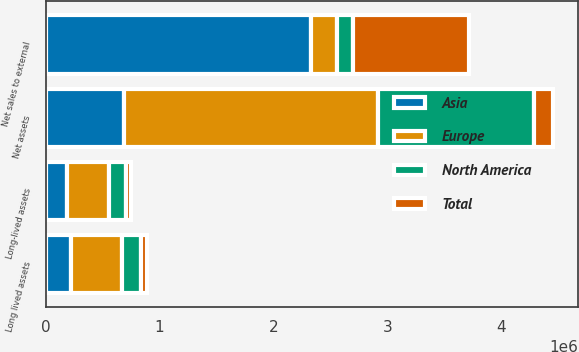Convert chart. <chart><loc_0><loc_0><loc_500><loc_500><stacked_bar_chart><ecel><fcel>Net sales to external<fcel>Long lived assets<fcel>Net assets<fcel>Long-lived assets<nl><fcel>Asia<fcel>2.33358e+06<fcel>221158<fcel>687638<fcel>185838<nl><fcel>North America<fcel>144740<fcel>168528<fcel>1.37124e+06<fcel>143181<nl><fcel>Total<fcel>1.01575e+06<fcel>55566<fcel>166976<fcel>45128<nl><fcel>Europe<fcel>221158<fcel>445252<fcel>2.22585e+06<fcel>374147<nl></chart> 